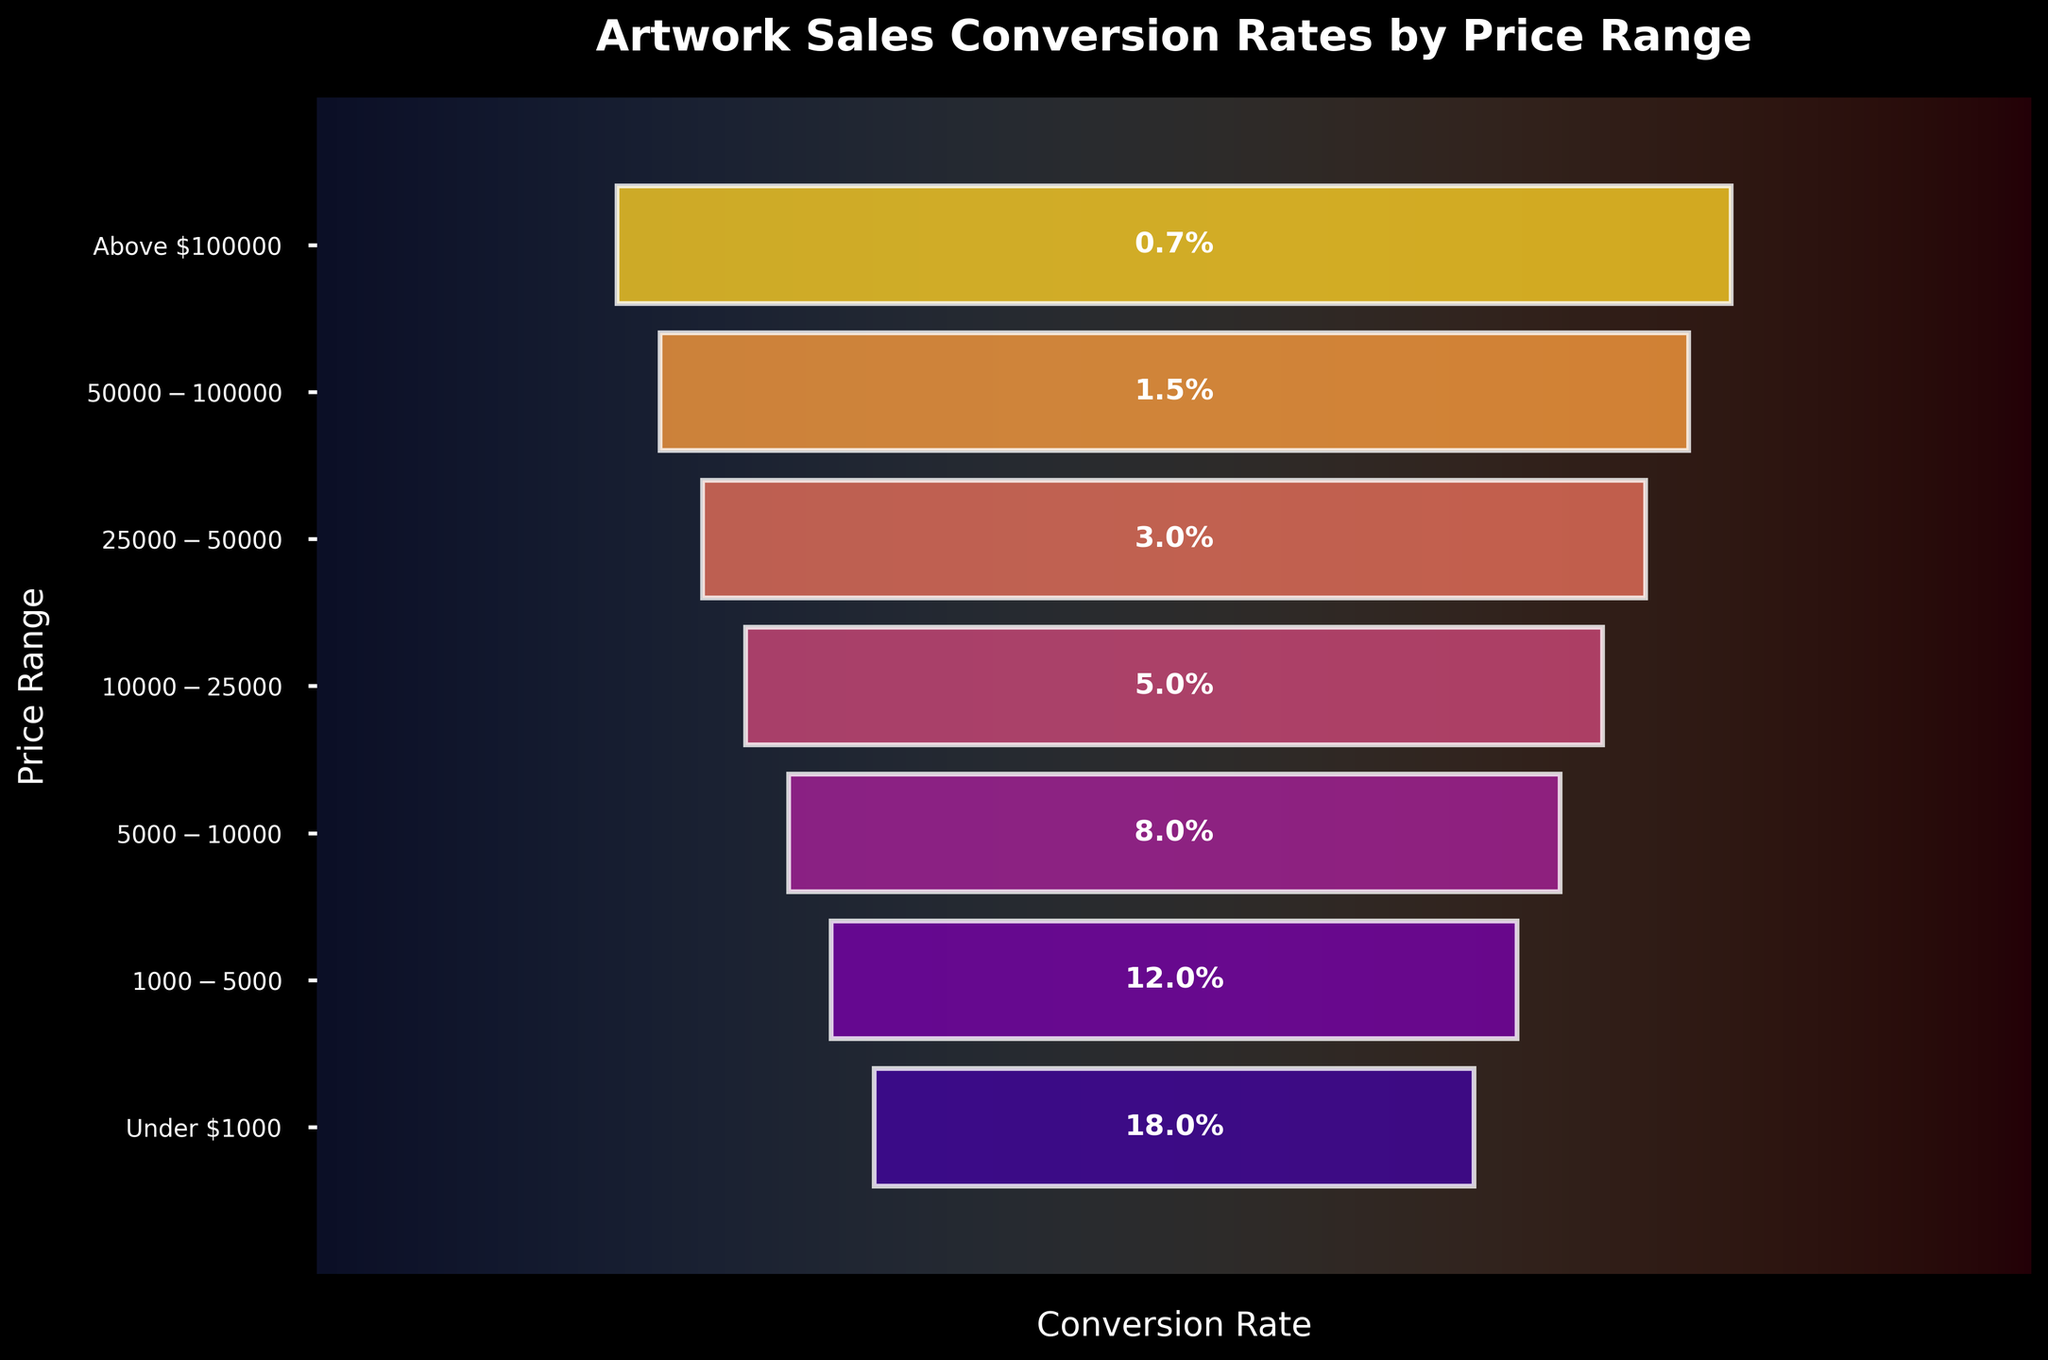What's the title of the chart? The title is usually displayed at the top of the chart. In this case, the title is "Artwork Sales Conversion Rates by Price Range."
Answer: Artwork Sales Conversion Rates by Price Range What color scheme is used for the bars? The colors of the bars are derived from the 'plasma' colormap, which presents a gradient ranging from blue to purple to yellow.
Answer: Blue to yellow gradient How many price ranges are displayed in the funnel chart? Count each unique price range listed on the y-axis labels. There are seven price ranges displayed in the funnel chart.
Answer: 7 What is the conversion rate for artworks under $1000? The conversion rate for each price range is labeled on the bar itself. The rate for artworks under $1000 is 18%.
Answer: 18% Which price range has the lowest conversion rate? By comparing the conversion rates listed on the bars, we see that the "Above $100000" price range has the lowest conversion rate of 0.7%.
Answer: Above $100000 How does the conversion rate change as the price range increases? As the price range increases, the conversion rate decreases. This pattern is noticeable as the rates decrease progressively down the list from 18% for the lowest range to 0.7% for the highest.
Answer: Decreases What is the difference in conversion rates between artworks priced $1000 - $5000 and $50000 - $100000? The conversion rate for $1000 - $5000 is 12% and for $50000 - $100000 is 1.5%. Subtracting these gives 12% - 1.5% = 10.5%.
Answer: 10.5% What is the average conversion rate for all the price ranges? Sum all conversion rates (18 + 12 + 8 + 5 + 3 + 1.5 + 0.7 = 48.2). Then, divide by the number of price ranges (7). The average is 48.2 / 7 ≈ 6.89%.
Answer: 6.89% Which price range shows a significant drop in conversion rate compared to the previous one? Looking at the drop between each consecutive price range, the drop from $1000 - $5000 (12%) to $5000 - $10000 (8%) shows a significant decrease of 4%.
Answer: $1000 - $5000 to $5000 - $10000 What visual element indicates the conversion rate within the funnel chart bars? The conversion rate is indicated by text labels inside each bar. These percentages are centered within the bars.
Answer: Text labels inside bars 